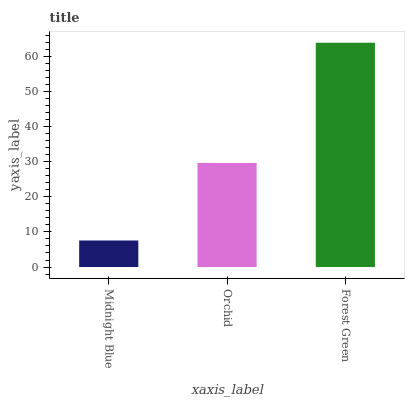Is Midnight Blue the minimum?
Answer yes or no. Yes. Is Forest Green the maximum?
Answer yes or no. Yes. Is Orchid the minimum?
Answer yes or no. No. Is Orchid the maximum?
Answer yes or no. No. Is Orchid greater than Midnight Blue?
Answer yes or no. Yes. Is Midnight Blue less than Orchid?
Answer yes or no. Yes. Is Midnight Blue greater than Orchid?
Answer yes or no. No. Is Orchid less than Midnight Blue?
Answer yes or no. No. Is Orchid the high median?
Answer yes or no. Yes. Is Orchid the low median?
Answer yes or no. Yes. Is Forest Green the high median?
Answer yes or no. No. Is Midnight Blue the low median?
Answer yes or no. No. 